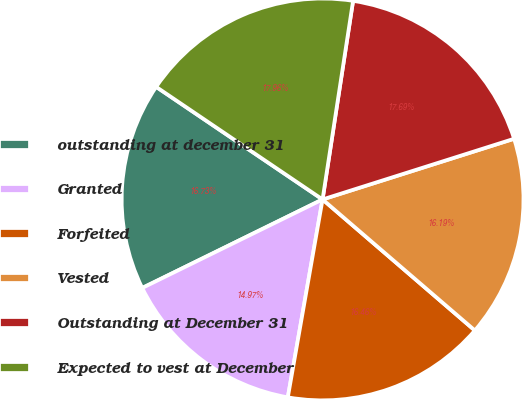Convert chart. <chart><loc_0><loc_0><loc_500><loc_500><pie_chart><fcel>outstanding at december 31<fcel>Granted<fcel>Forfeited<fcel>Vested<fcel>Outstanding at December 31<fcel>Expected to vest at December<nl><fcel>16.73%<fcel>14.97%<fcel>16.46%<fcel>16.19%<fcel>17.69%<fcel>17.96%<nl></chart> 